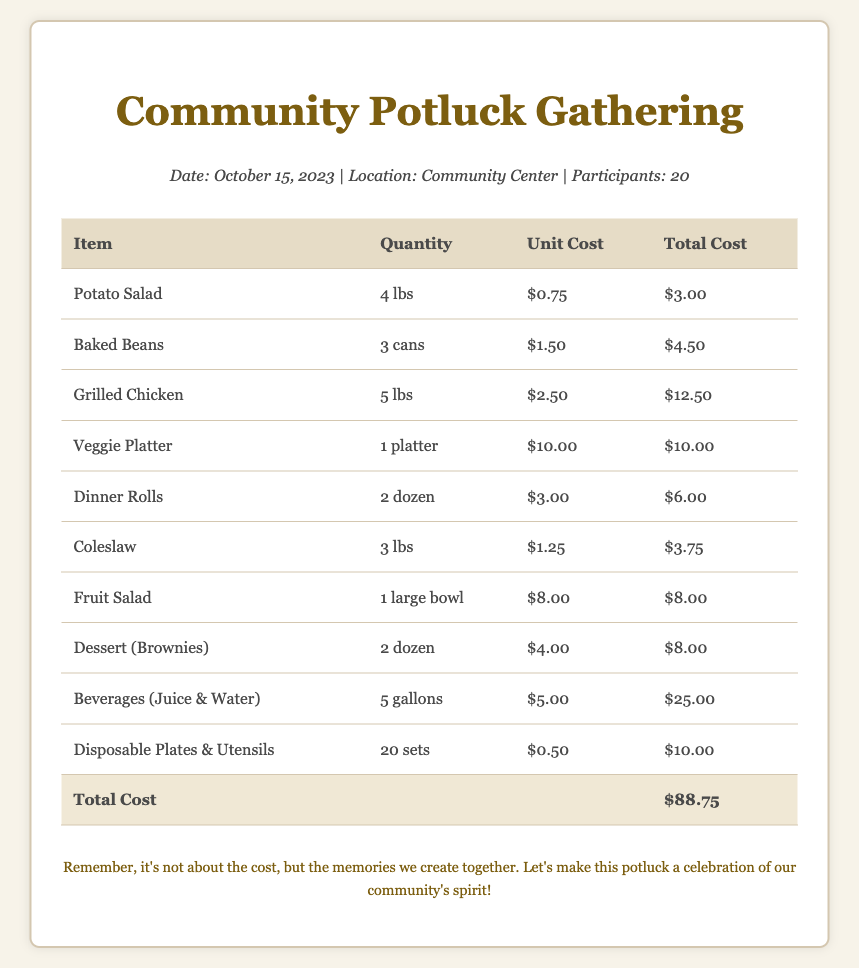What is the date of the potluck? The date of the potluck is mentioned in the event details section of the document.
Answer: October 15, 2023 Where is the potluck held? The location of the potluck is specified in the event details section.
Answer: Community Center How many participants are expected? The number of participants is noted in the event details section.
Answer: 20 What is the total cost of the groceries? The total cost is listed at the bottom of the itemized table.
Answer: $88.75 How much does the baked beans cost? The cost for baked beans is provided in the itemized list.
Answer: $4.50 What item has the highest unit cost? The item with the highest unit cost can be found by comparing all unit costs in the document.
Answer: Beverages (Juice & Water) How many pounds of grilled chicken were purchased? The quantity of grilled chicken is detailed in the itemized table.
Answer: 5 lbs What is the cost of disposable plates and utensils? The cost for disposable plates and utensils is included in the itemized section.
Answer: $10.00 What type of dessert is provided? The type of dessert is mentioned in the itemized list.
Answer: Brownies 